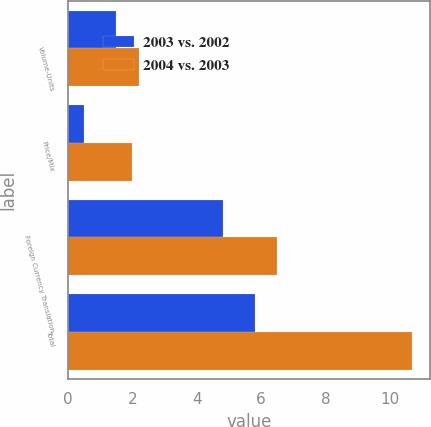<chart> <loc_0><loc_0><loc_500><loc_500><stacked_bar_chart><ecel><fcel>Volume-Units<fcel>Price/Mix<fcel>Foreign Currency Translation<fcel>Total<nl><fcel>2003 vs. 2002<fcel>1.5<fcel>0.5<fcel>4.8<fcel>5.8<nl><fcel>2004 vs. 2003<fcel>2.2<fcel>2<fcel>6.5<fcel>10.7<nl></chart> 